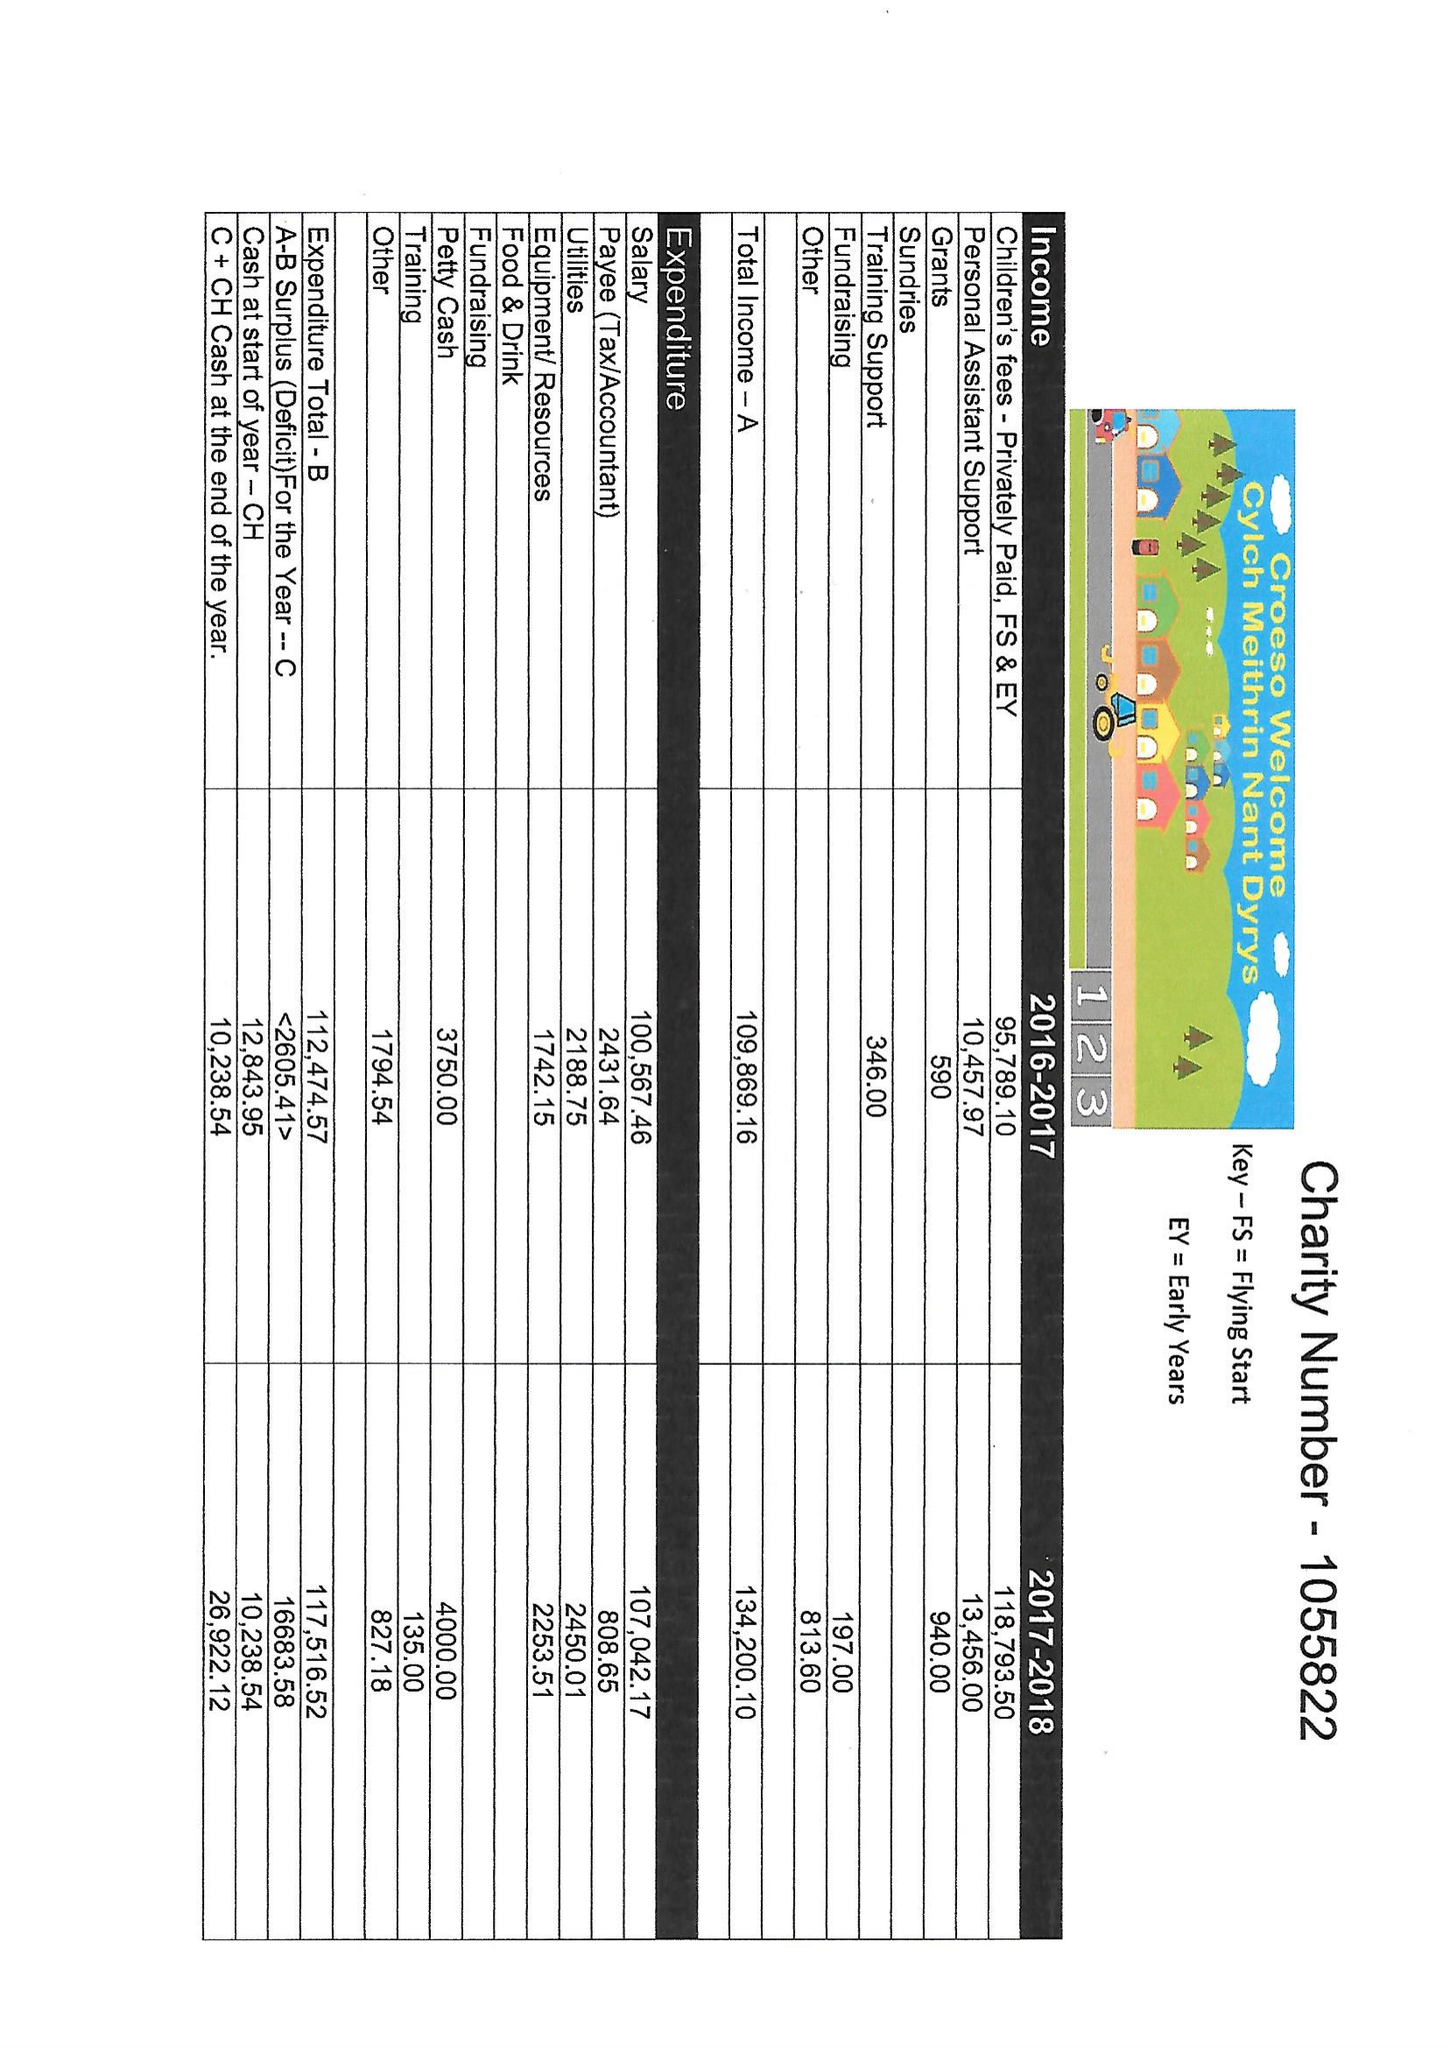What is the value for the spending_annually_in_british_pounds?
Answer the question using a single word or phrase. 117517.00 